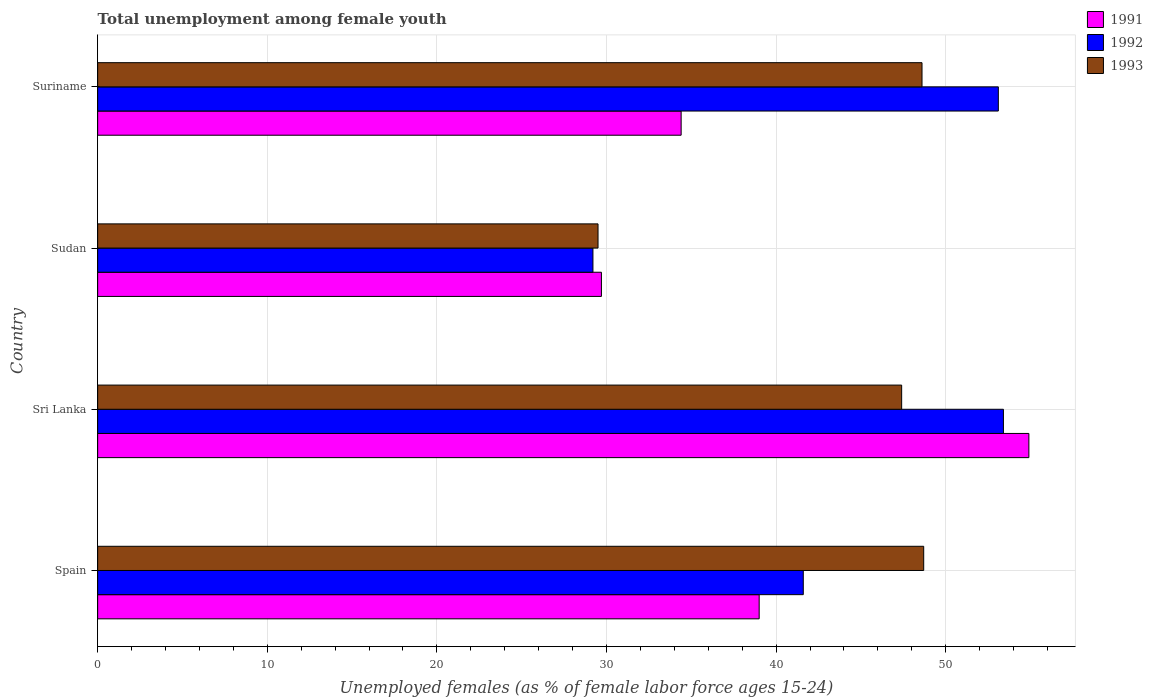How many different coloured bars are there?
Keep it short and to the point. 3. How many groups of bars are there?
Give a very brief answer. 4. How many bars are there on the 1st tick from the top?
Give a very brief answer. 3. What is the label of the 3rd group of bars from the top?
Your answer should be very brief. Sri Lanka. What is the percentage of unemployed females in in 1993 in Sri Lanka?
Your response must be concise. 47.4. Across all countries, what is the maximum percentage of unemployed females in in 1992?
Keep it short and to the point. 53.4. Across all countries, what is the minimum percentage of unemployed females in in 1993?
Keep it short and to the point. 29.5. In which country was the percentage of unemployed females in in 1992 maximum?
Make the answer very short. Sri Lanka. In which country was the percentage of unemployed females in in 1992 minimum?
Your answer should be very brief. Sudan. What is the total percentage of unemployed females in in 1993 in the graph?
Make the answer very short. 174.2. What is the difference between the percentage of unemployed females in in 1991 in Spain and that in Suriname?
Offer a very short reply. 4.6. What is the difference between the percentage of unemployed females in in 1991 in Sudan and the percentage of unemployed females in in 1992 in Suriname?
Make the answer very short. -23.4. What is the average percentage of unemployed females in in 1993 per country?
Make the answer very short. 43.55. What is the difference between the percentage of unemployed females in in 1991 and percentage of unemployed females in in 1993 in Sudan?
Keep it short and to the point. 0.2. What is the ratio of the percentage of unemployed females in in 1992 in Spain to that in Sudan?
Your response must be concise. 1.42. What is the difference between the highest and the second highest percentage of unemployed females in in 1991?
Your response must be concise. 15.9. What is the difference between the highest and the lowest percentage of unemployed females in in 1991?
Your answer should be very brief. 25.2. Is the sum of the percentage of unemployed females in in 1993 in Spain and Sudan greater than the maximum percentage of unemployed females in in 1992 across all countries?
Provide a succinct answer. Yes. What does the 2nd bar from the bottom in Suriname represents?
Your answer should be compact. 1992. How many bars are there?
Your answer should be compact. 12. Are all the bars in the graph horizontal?
Make the answer very short. Yes. Does the graph contain any zero values?
Keep it short and to the point. No. Where does the legend appear in the graph?
Your response must be concise. Top right. What is the title of the graph?
Ensure brevity in your answer.  Total unemployment among female youth. What is the label or title of the X-axis?
Make the answer very short. Unemployed females (as % of female labor force ages 15-24). What is the label or title of the Y-axis?
Make the answer very short. Country. What is the Unemployed females (as % of female labor force ages 15-24) of 1991 in Spain?
Provide a short and direct response. 39. What is the Unemployed females (as % of female labor force ages 15-24) in 1992 in Spain?
Give a very brief answer. 41.6. What is the Unemployed females (as % of female labor force ages 15-24) in 1993 in Spain?
Your answer should be very brief. 48.7. What is the Unemployed females (as % of female labor force ages 15-24) of 1991 in Sri Lanka?
Your response must be concise. 54.9. What is the Unemployed females (as % of female labor force ages 15-24) in 1992 in Sri Lanka?
Ensure brevity in your answer.  53.4. What is the Unemployed females (as % of female labor force ages 15-24) of 1993 in Sri Lanka?
Your answer should be compact. 47.4. What is the Unemployed females (as % of female labor force ages 15-24) in 1991 in Sudan?
Make the answer very short. 29.7. What is the Unemployed females (as % of female labor force ages 15-24) in 1992 in Sudan?
Ensure brevity in your answer.  29.2. What is the Unemployed females (as % of female labor force ages 15-24) of 1993 in Sudan?
Your answer should be very brief. 29.5. What is the Unemployed females (as % of female labor force ages 15-24) of 1991 in Suriname?
Offer a very short reply. 34.4. What is the Unemployed females (as % of female labor force ages 15-24) in 1992 in Suriname?
Provide a succinct answer. 53.1. What is the Unemployed females (as % of female labor force ages 15-24) of 1993 in Suriname?
Make the answer very short. 48.6. Across all countries, what is the maximum Unemployed females (as % of female labor force ages 15-24) of 1991?
Provide a succinct answer. 54.9. Across all countries, what is the maximum Unemployed females (as % of female labor force ages 15-24) in 1992?
Your answer should be very brief. 53.4. Across all countries, what is the maximum Unemployed females (as % of female labor force ages 15-24) of 1993?
Your response must be concise. 48.7. Across all countries, what is the minimum Unemployed females (as % of female labor force ages 15-24) in 1991?
Provide a succinct answer. 29.7. Across all countries, what is the minimum Unemployed females (as % of female labor force ages 15-24) of 1992?
Offer a very short reply. 29.2. Across all countries, what is the minimum Unemployed females (as % of female labor force ages 15-24) in 1993?
Give a very brief answer. 29.5. What is the total Unemployed females (as % of female labor force ages 15-24) of 1991 in the graph?
Your response must be concise. 158. What is the total Unemployed females (as % of female labor force ages 15-24) in 1992 in the graph?
Make the answer very short. 177.3. What is the total Unemployed females (as % of female labor force ages 15-24) in 1993 in the graph?
Provide a succinct answer. 174.2. What is the difference between the Unemployed females (as % of female labor force ages 15-24) of 1991 in Spain and that in Sri Lanka?
Offer a terse response. -15.9. What is the difference between the Unemployed females (as % of female labor force ages 15-24) of 1992 in Spain and that in Sri Lanka?
Keep it short and to the point. -11.8. What is the difference between the Unemployed females (as % of female labor force ages 15-24) of 1993 in Spain and that in Sri Lanka?
Provide a short and direct response. 1.3. What is the difference between the Unemployed females (as % of female labor force ages 15-24) of 1991 in Spain and that in Suriname?
Your answer should be compact. 4.6. What is the difference between the Unemployed females (as % of female labor force ages 15-24) in 1992 in Spain and that in Suriname?
Offer a very short reply. -11.5. What is the difference between the Unemployed females (as % of female labor force ages 15-24) in 1993 in Spain and that in Suriname?
Your answer should be very brief. 0.1. What is the difference between the Unemployed females (as % of female labor force ages 15-24) of 1991 in Sri Lanka and that in Sudan?
Your answer should be very brief. 25.2. What is the difference between the Unemployed females (as % of female labor force ages 15-24) in 1992 in Sri Lanka and that in Sudan?
Offer a very short reply. 24.2. What is the difference between the Unemployed females (as % of female labor force ages 15-24) in 1991 in Sri Lanka and that in Suriname?
Offer a very short reply. 20.5. What is the difference between the Unemployed females (as % of female labor force ages 15-24) of 1993 in Sri Lanka and that in Suriname?
Your answer should be very brief. -1.2. What is the difference between the Unemployed females (as % of female labor force ages 15-24) in 1991 in Sudan and that in Suriname?
Make the answer very short. -4.7. What is the difference between the Unemployed females (as % of female labor force ages 15-24) in 1992 in Sudan and that in Suriname?
Ensure brevity in your answer.  -23.9. What is the difference between the Unemployed females (as % of female labor force ages 15-24) in 1993 in Sudan and that in Suriname?
Ensure brevity in your answer.  -19.1. What is the difference between the Unemployed females (as % of female labor force ages 15-24) in 1991 in Spain and the Unemployed females (as % of female labor force ages 15-24) in 1992 in Sri Lanka?
Your response must be concise. -14.4. What is the difference between the Unemployed females (as % of female labor force ages 15-24) in 1991 in Spain and the Unemployed females (as % of female labor force ages 15-24) in 1993 in Sri Lanka?
Provide a succinct answer. -8.4. What is the difference between the Unemployed females (as % of female labor force ages 15-24) in 1992 in Spain and the Unemployed females (as % of female labor force ages 15-24) in 1993 in Sri Lanka?
Offer a very short reply. -5.8. What is the difference between the Unemployed females (as % of female labor force ages 15-24) of 1991 in Spain and the Unemployed females (as % of female labor force ages 15-24) of 1992 in Sudan?
Your response must be concise. 9.8. What is the difference between the Unemployed females (as % of female labor force ages 15-24) in 1991 in Spain and the Unemployed females (as % of female labor force ages 15-24) in 1992 in Suriname?
Ensure brevity in your answer.  -14.1. What is the difference between the Unemployed females (as % of female labor force ages 15-24) in 1991 in Spain and the Unemployed females (as % of female labor force ages 15-24) in 1993 in Suriname?
Offer a very short reply. -9.6. What is the difference between the Unemployed females (as % of female labor force ages 15-24) in 1992 in Spain and the Unemployed females (as % of female labor force ages 15-24) in 1993 in Suriname?
Keep it short and to the point. -7. What is the difference between the Unemployed females (as % of female labor force ages 15-24) in 1991 in Sri Lanka and the Unemployed females (as % of female labor force ages 15-24) in 1992 in Sudan?
Provide a short and direct response. 25.7. What is the difference between the Unemployed females (as % of female labor force ages 15-24) in 1991 in Sri Lanka and the Unemployed females (as % of female labor force ages 15-24) in 1993 in Sudan?
Give a very brief answer. 25.4. What is the difference between the Unemployed females (as % of female labor force ages 15-24) of 1992 in Sri Lanka and the Unemployed females (as % of female labor force ages 15-24) of 1993 in Sudan?
Offer a terse response. 23.9. What is the difference between the Unemployed females (as % of female labor force ages 15-24) in 1991 in Sri Lanka and the Unemployed females (as % of female labor force ages 15-24) in 1993 in Suriname?
Your answer should be compact. 6.3. What is the difference between the Unemployed females (as % of female labor force ages 15-24) of 1991 in Sudan and the Unemployed females (as % of female labor force ages 15-24) of 1992 in Suriname?
Give a very brief answer. -23.4. What is the difference between the Unemployed females (as % of female labor force ages 15-24) of 1991 in Sudan and the Unemployed females (as % of female labor force ages 15-24) of 1993 in Suriname?
Your answer should be very brief. -18.9. What is the difference between the Unemployed females (as % of female labor force ages 15-24) of 1992 in Sudan and the Unemployed females (as % of female labor force ages 15-24) of 1993 in Suriname?
Your answer should be very brief. -19.4. What is the average Unemployed females (as % of female labor force ages 15-24) of 1991 per country?
Provide a short and direct response. 39.5. What is the average Unemployed females (as % of female labor force ages 15-24) of 1992 per country?
Your answer should be compact. 44.33. What is the average Unemployed females (as % of female labor force ages 15-24) of 1993 per country?
Your answer should be very brief. 43.55. What is the difference between the Unemployed females (as % of female labor force ages 15-24) in 1991 and Unemployed females (as % of female labor force ages 15-24) in 1992 in Spain?
Your answer should be very brief. -2.6. What is the difference between the Unemployed females (as % of female labor force ages 15-24) in 1991 and Unemployed females (as % of female labor force ages 15-24) in 1993 in Spain?
Provide a short and direct response. -9.7. What is the difference between the Unemployed females (as % of female labor force ages 15-24) in 1991 and Unemployed females (as % of female labor force ages 15-24) in 1992 in Sri Lanka?
Your answer should be compact. 1.5. What is the difference between the Unemployed females (as % of female labor force ages 15-24) of 1991 and Unemployed females (as % of female labor force ages 15-24) of 1993 in Sri Lanka?
Ensure brevity in your answer.  7.5. What is the difference between the Unemployed females (as % of female labor force ages 15-24) of 1992 and Unemployed females (as % of female labor force ages 15-24) of 1993 in Sudan?
Keep it short and to the point. -0.3. What is the difference between the Unemployed females (as % of female labor force ages 15-24) of 1991 and Unemployed females (as % of female labor force ages 15-24) of 1992 in Suriname?
Provide a succinct answer. -18.7. What is the difference between the Unemployed females (as % of female labor force ages 15-24) of 1991 and Unemployed females (as % of female labor force ages 15-24) of 1993 in Suriname?
Offer a very short reply. -14.2. What is the ratio of the Unemployed females (as % of female labor force ages 15-24) in 1991 in Spain to that in Sri Lanka?
Offer a terse response. 0.71. What is the ratio of the Unemployed females (as % of female labor force ages 15-24) in 1992 in Spain to that in Sri Lanka?
Your answer should be compact. 0.78. What is the ratio of the Unemployed females (as % of female labor force ages 15-24) in 1993 in Spain to that in Sri Lanka?
Offer a terse response. 1.03. What is the ratio of the Unemployed females (as % of female labor force ages 15-24) in 1991 in Spain to that in Sudan?
Keep it short and to the point. 1.31. What is the ratio of the Unemployed females (as % of female labor force ages 15-24) in 1992 in Spain to that in Sudan?
Give a very brief answer. 1.42. What is the ratio of the Unemployed females (as % of female labor force ages 15-24) of 1993 in Spain to that in Sudan?
Keep it short and to the point. 1.65. What is the ratio of the Unemployed females (as % of female labor force ages 15-24) in 1991 in Spain to that in Suriname?
Offer a terse response. 1.13. What is the ratio of the Unemployed females (as % of female labor force ages 15-24) of 1992 in Spain to that in Suriname?
Provide a short and direct response. 0.78. What is the ratio of the Unemployed females (as % of female labor force ages 15-24) of 1991 in Sri Lanka to that in Sudan?
Your response must be concise. 1.85. What is the ratio of the Unemployed females (as % of female labor force ages 15-24) of 1992 in Sri Lanka to that in Sudan?
Give a very brief answer. 1.83. What is the ratio of the Unemployed females (as % of female labor force ages 15-24) in 1993 in Sri Lanka to that in Sudan?
Your answer should be very brief. 1.61. What is the ratio of the Unemployed females (as % of female labor force ages 15-24) of 1991 in Sri Lanka to that in Suriname?
Ensure brevity in your answer.  1.6. What is the ratio of the Unemployed females (as % of female labor force ages 15-24) in 1992 in Sri Lanka to that in Suriname?
Give a very brief answer. 1.01. What is the ratio of the Unemployed females (as % of female labor force ages 15-24) of 1993 in Sri Lanka to that in Suriname?
Your answer should be very brief. 0.98. What is the ratio of the Unemployed females (as % of female labor force ages 15-24) of 1991 in Sudan to that in Suriname?
Provide a short and direct response. 0.86. What is the ratio of the Unemployed females (as % of female labor force ages 15-24) of 1992 in Sudan to that in Suriname?
Give a very brief answer. 0.55. What is the ratio of the Unemployed females (as % of female labor force ages 15-24) in 1993 in Sudan to that in Suriname?
Keep it short and to the point. 0.61. What is the difference between the highest and the second highest Unemployed females (as % of female labor force ages 15-24) of 1991?
Offer a very short reply. 15.9. What is the difference between the highest and the second highest Unemployed females (as % of female labor force ages 15-24) of 1993?
Provide a succinct answer. 0.1. What is the difference between the highest and the lowest Unemployed females (as % of female labor force ages 15-24) in 1991?
Make the answer very short. 25.2. What is the difference between the highest and the lowest Unemployed females (as % of female labor force ages 15-24) of 1992?
Your answer should be very brief. 24.2. What is the difference between the highest and the lowest Unemployed females (as % of female labor force ages 15-24) in 1993?
Give a very brief answer. 19.2. 